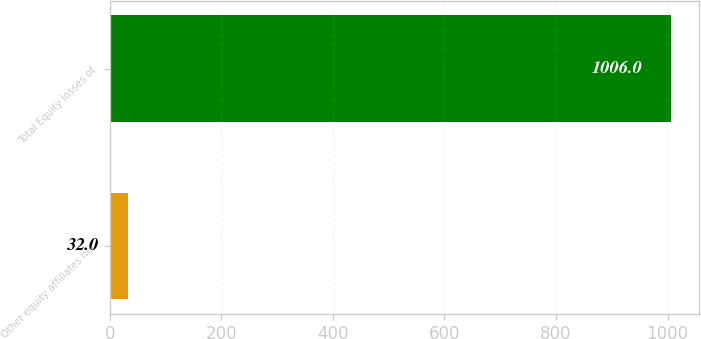Convert chart to OTSL. <chart><loc_0><loc_0><loc_500><loc_500><bar_chart><fcel>Other equity affiliates net<fcel>Total Equity losses of<nl><fcel>32<fcel>1006<nl></chart> 